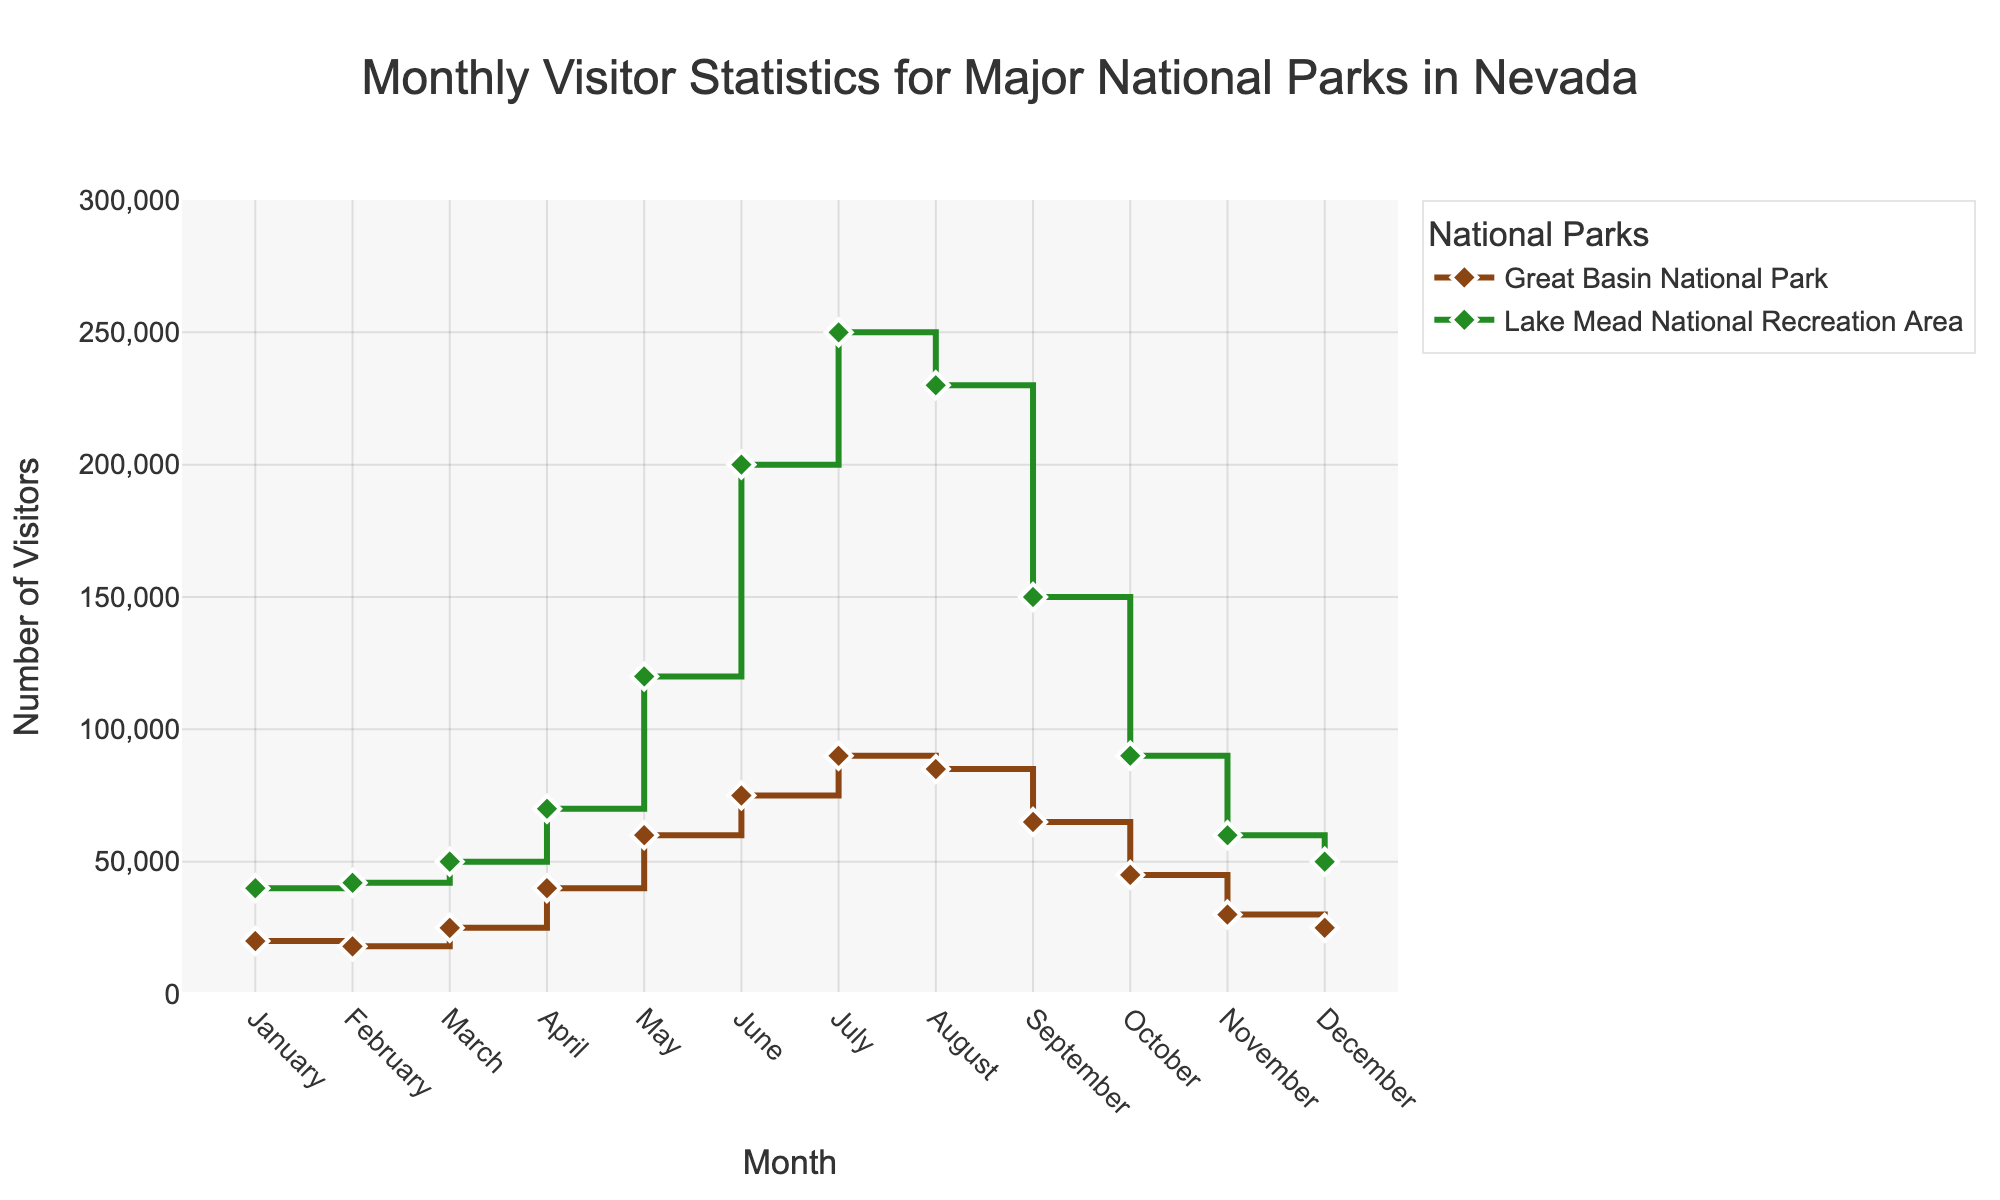What's the title of the figure? The title is located at the top center of the figure and reads 'Monthly Visitor Statistics for Major National Parks in Nevada'.
Answer: Monthly Visitor Statistics for Major National Parks in Nevada What is the highest number of visitors for Lake Mead National Recreation Area? Find the peak point on the line corresponding to Lake Mead National Recreation Area, which is colored in green. The highest point on this line reaches 250,000 visitors.
Answer: 250,000 In which month did Great Basin National Park have the most visitors? Find the peak of the brown line associated with Great Basin National Park. The highest point is in July, where the visitors are 90,000.
Answer: July What's the difference in the number of visitors between Great Basin National Park and Lake Mead National Recreation Area in May? First, identify the number of visitors for both parks in May. Great Basin has 60,000 visitors, and Lake Mead has 120,000 visitors. Subtract the smaller number from the larger one (120,000 - 60,000) to find the difference.
Answer: 60,000 In which month do both parks have the closest number of visitors? Compare the two lines month by month to find the month where the difference in visitor numbers between both parks is the least. The figures for October are 45,000 (Great Basin) and 90,000 (Lake Mead), resulting in a difference of 45,000, which is the smallest among all months compared.
Answer: October How many months did each park have fewer than 50,000 visitors? Count the months where the visitor numbers for each park fall below 50,000. Great Basin National Park has fewer than 50,000 visitors in January, February, March, October, November, and December. Lake Mead National Recreation Area has fewer than 50,000 visitors in January, February, November, and December. This constitutes 6 months for Great Basin and 4 months for Lake Mead.
Answer: 6 for Great Basin, 4 for Lake Mead What is the average number of visitors in November across both parks? Add the number of visitors for Great Basin (30,000) and Lake Mead (60,000) in November and divide by 2 to find the average. (30,000 + 60,000) / 2 = 45,000
Answer: 45,000 Which park had a more significant increase in visitors from April to May? Calculate the difference in visitors from April to May for each park. Great Basin increases from 40,000 to 60,000, equating to an increase of 20,000. Lake Mead increases from 70,000 to 120,000, which is an increase of 50,000. Lake Mead has the more significant increase.
Answer: Lake Mead National Recreation Area Can you identify any seasonal patterns for either park from the graph? Look at the trends over the months to note any recurring patterns. Both parks show a significant rise in visitors from winter to summer, peaking in summer (July for Great Basin and July for Lake Mead) and then experiencing a decline towards the winter months. The specific pattern is higher visitor numbers in summer and lower in winter for both parks.
Answer: Higher in summer, lower in winter Which park has a more consistent range of visitor numbers throughout the year? Assess the variability in the visitor numbers for each park throughout the months. The visitor numbers for Great Basin National Park vary from 18,000 to 90,000, whereas Lake Mead's numbers range from 40,000 to 250,000. Given the smaller range, Great Basin exhibits more consistent visitor numbers.
Answer: Great Basin National Park 